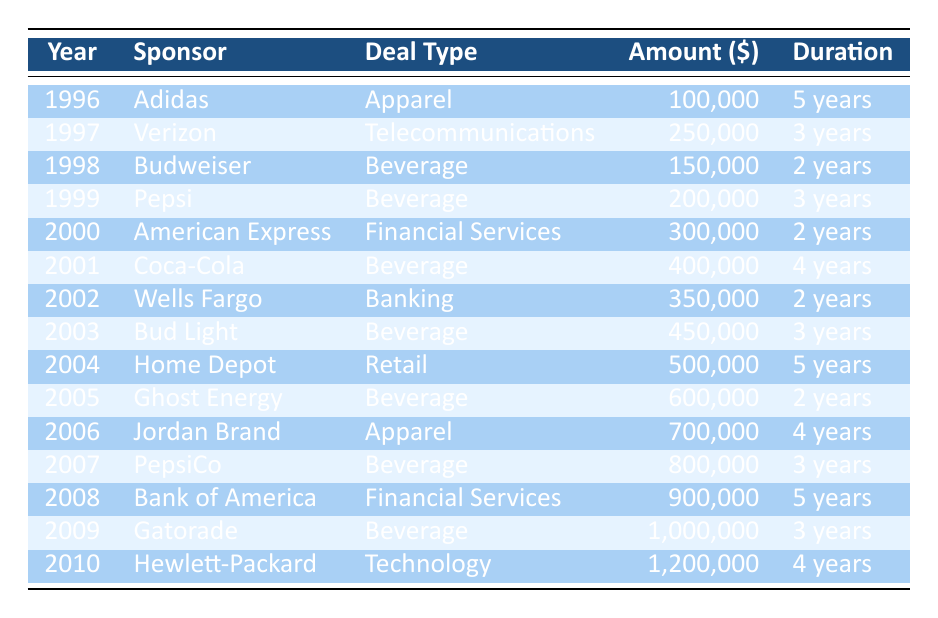What was the amount of the sponsorship deal with Pepsi in 1999? From the table, the row for the year 1999 indicates that the sponsor Pepsi had a deal amount of 200,000.
Answer: 200,000 Which sponsor had the highest deal amount in 2010? The table shows that Hewlett-Packard had the highest deal amount in 2010, which is listed as 1,200,000.
Answer: 1,200,000 How many years did the Coca-Cola sponsorship last? Referring to the table, Coca-Cola's deal type indicates a duration of 4 years, which directly answers the question.
Answer: 4 years What is the total revenue generated from sponsorships in the years 2004 to 2006? To find the total revenue in these years, we sum the amounts: 500,000 (2004) + 600,000 (2005) + 700,000 (2006) = 1,800,000.
Answer: 1,800,000 Did the amount of sponsorship deals increase every year from 1996 to 2010? By examining the table, we can see that the amounts generally increased, however, there are years (like 1998 and 1999) where the amounts decreased (150,000 to 200,000), hence, the answer is no.
Answer: No Which sponsor appeared first, Adidas or Gatorade? Looking at the table, Adidas is listed in 1996 and Gatorade in 2009, establishing that Adidas appeared first.
Answer: Adidas What was the average deal amount across all sponsorships from 1996 to 2010? We first sum all the sponsorship amounts listed in the table: 100,000 + 250,000 + 150,000 + 200,000 + 300,000 + 400,000 + 350,000 + 450,000 + 500,000 + 600,000 + 700,000 + 800,000 + 900,000 + 1,000,000 + 1,200,000 = 6,450,000. Then we divide this total by the 15 deals, the average is 6,450,000 / 15 ≈ 430,000.
Answer: 430,000 What percentage of the total sponsorship amount do Beverage deals represent from 1996 to 2010? We find the total amount of Beverage deals by summing: 150,000 + 200,000 + 400,000 + 450,000 + 600,000 + 800,000 + 900,000 + 1,000,000 = 3,700,000. The total sponsorship amount is 6,450,000, so the percentage is (3,700,000 / 6,450,000) * 100 ≈ 57.28%.
Answer: Approximately 57.28% Which sponsor had a deal that lasted for only 2 years? The table indicates several sponsors with a 2-year duration, specifically Budweiser, American Express, Wells Fargo, and Ghost Energy. Thus, there are multiple answers.
Answer: Budweiser, American Express, Wells Fargo, Ghost Energy 